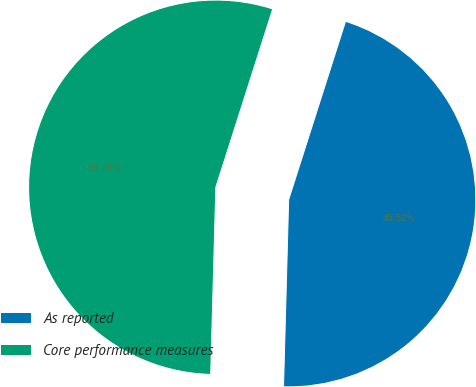Convert chart. <chart><loc_0><loc_0><loc_500><loc_500><pie_chart><fcel>As reported<fcel>Core performance measures<nl><fcel>45.52%<fcel>54.48%<nl></chart> 